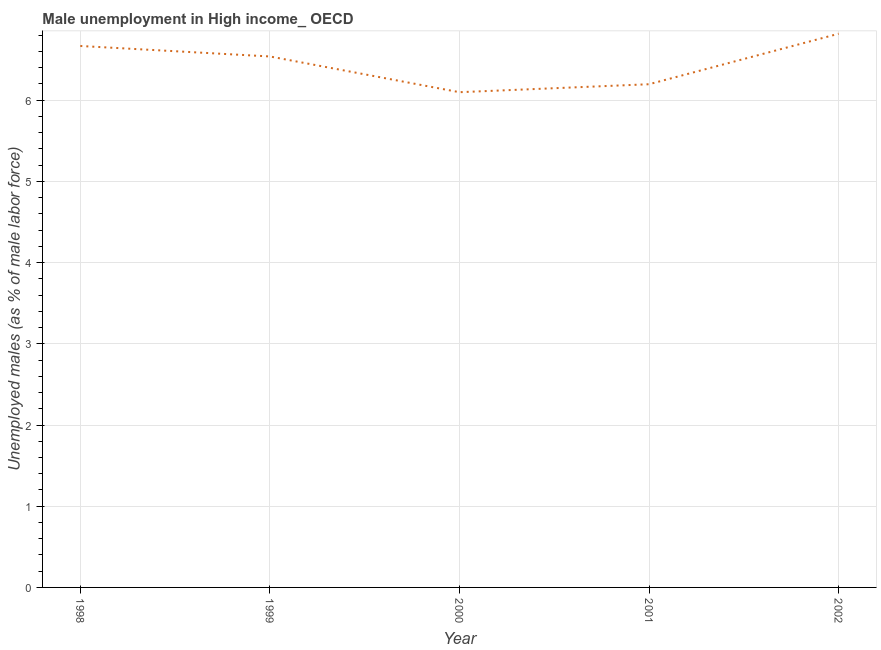What is the unemployed males population in 1999?
Your answer should be very brief. 6.54. Across all years, what is the maximum unemployed males population?
Keep it short and to the point. 6.82. Across all years, what is the minimum unemployed males population?
Offer a very short reply. 6.1. In which year was the unemployed males population maximum?
Provide a short and direct response. 2002. What is the sum of the unemployed males population?
Give a very brief answer. 32.32. What is the difference between the unemployed males population in 1998 and 1999?
Provide a short and direct response. 0.13. What is the average unemployed males population per year?
Offer a terse response. 6.46. What is the median unemployed males population?
Offer a terse response. 6.54. Do a majority of the years between 1998 and 2000 (inclusive) have unemployed males population greater than 3 %?
Offer a terse response. Yes. What is the ratio of the unemployed males population in 2001 to that in 2002?
Your response must be concise. 0.91. Is the unemployed males population in 1998 less than that in 2001?
Your answer should be compact. No. Is the difference between the unemployed males population in 2000 and 2002 greater than the difference between any two years?
Provide a succinct answer. Yes. What is the difference between the highest and the second highest unemployed males population?
Provide a succinct answer. 0.15. Is the sum of the unemployed males population in 2000 and 2002 greater than the maximum unemployed males population across all years?
Provide a short and direct response. Yes. What is the difference between the highest and the lowest unemployed males population?
Make the answer very short. 0.72. In how many years, is the unemployed males population greater than the average unemployed males population taken over all years?
Offer a terse response. 3. Does the unemployed males population monotonically increase over the years?
Your response must be concise. No. How many lines are there?
Give a very brief answer. 1. What is the difference between two consecutive major ticks on the Y-axis?
Your response must be concise. 1. What is the title of the graph?
Ensure brevity in your answer.  Male unemployment in High income_ OECD. What is the label or title of the X-axis?
Keep it short and to the point. Year. What is the label or title of the Y-axis?
Ensure brevity in your answer.  Unemployed males (as % of male labor force). What is the Unemployed males (as % of male labor force) in 1998?
Your response must be concise. 6.67. What is the Unemployed males (as % of male labor force) in 1999?
Your answer should be compact. 6.54. What is the Unemployed males (as % of male labor force) in 2000?
Your answer should be compact. 6.1. What is the Unemployed males (as % of male labor force) in 2001?
Offer a terse response. 6.2. What is the Unemployed males (as % of male labor force) of 2002?
Keep it short and to the point. 6.82. What is the difference between the Unemployed males (as % of male labor force) in 1998 and 1999?
Give a very brief answer. 0.13. What is the difference between the Unemployed males (as % of male labor force) in 1998 and 2000?
Ensure brevity in your answer.  0.57. What is the difference between the Unemployed males (as % of male labor force) in 1998 and 2001?
Provide a short and direct response. 0.47. What is the difference between the Unemployed males (as % of male labor force) in 1998 and 2002?
Give a very brief answer. -0.15. What is the difference between the Unemployed males (as % of male labor force) in 1999 and 2000?
Your answer should be very brief. 0.44. What is the difference between the Unemployed males (as % of male labor force) in 1999 and 2001?
Your answer should be very brief. 0.34. What is the difference between the Unemployed males (as % of male labor force) in 1999 and 2002?
Keep it short and to the point. -0.28. What is the difference between the Unemployed males (as % of male labor force) in 2000 and 2001?
Your answer should be compact. -0.1. What is the difference between the Unemployed males (as % of male labor force) in 2000 and 2002?
Make the answer very short. -0.72. What is the difference between the Unemployed males (as % of male labor force) in 2001 and 2002?
Offer a very short reply. -0.62. What is the ratio of the Unemployed males (as % of male labor force) in 1998 to that in 1999?
Offer a terse response. 1.02. What is the ratio of the Unemployed males (as % of male labor force) in 1998 to that in 2000?
Keep it short and to the point. 1.09. What is the ratio of the Unemployed males (as % of male labor force) in 1998 to that in 2001?
Provide a short and direct response. 1.08. What is the ratio of the Unemployed males (as % of male labor force) in 1998 to that in 2002?
Ensure brevity in your answer.  0.98. What is the ratio of the Unemployed males (as % of male labor force) in 1999 to that in 2000?
Keep it short and to the point. 1.07. What is the ratio of the Unemployed males (as % of male labor force) in 1999 to that in 2001?
Your answer should be very brief. 1.05. What is the ratio of the Unemployed males (as % of male labor force) in 1999 to that in 2002?
Keep it short and to the point. 0.96. What is the ratio of the Unemployed males (as % of male labor force) in 2000 to that in 2001?
Ensure brevity in your answer.  0.98. What is the ratio of the Unemployed males (as % of male labor force) in 2000 to that in 2002?
Offer a terse response. 0.89. What is the ratio of the Unemployed males (as % of male labor force) in 2001 to that in 2002?
Offer a very short reply. 0.91. 